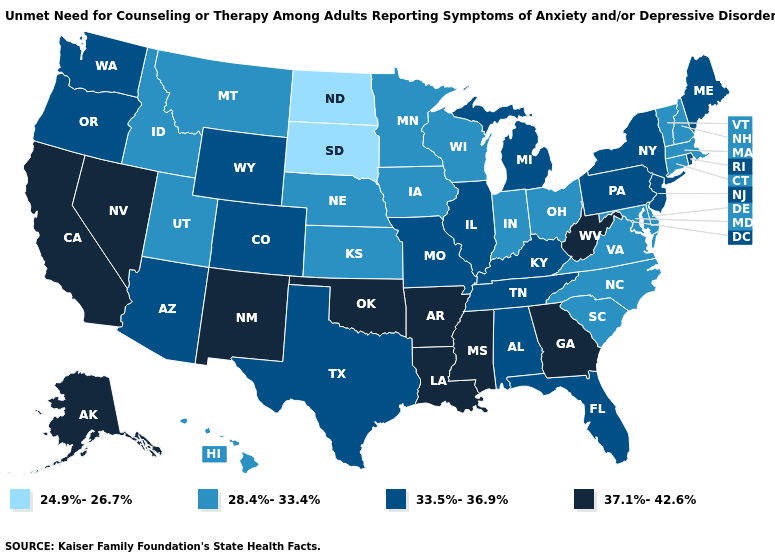Which states hav the highest value in the MidWest?
Write a very short answer. Illinois, Michigan, Missouri. What is the value of Louisiana?
Concise answer only. 37.1%-42.6%. What is the lowest value in the USA?
Concise answer only. 24.9%-26.7%. Does North Dakota have the lowest value in the USA?
Write a very short answer. Yes. What is the value of Indiana?
Concise answer only. 28.4%-33.4%. What is the lowest value in states that border Connecticut?
Keep it brief. 28.4%-33.4%. How many symbols are there in the legend?
Write a very short answer. 4. What is the value of Tennessee?
Give a very brief answer. 33.5%-36.9%. Among the states that border Kansas , which have the highest value?
Quick response, please. Oklahoma. What is the value of Oregon?
Write a very short answer. 33.5%-36.9%. Does Kentucky have the same value as South Carolina?
Keep it brief. No. What is the value of Arkansas?
Keep it brief. 37.1%-42.6%. What is the value of Alabama?
Write a very short answer. 33.5%-36.9%. What is the value of Michigan?
Keep it brief. 33.5%-36.9%. Name the states that have a value in the range 37.1%-42.6%?
Quick response, please. Alaska, Arkansas, California, Georgia, Louisiana, Mississippi, Nevada, New Mexico, Oklahoma, West Virginia. 